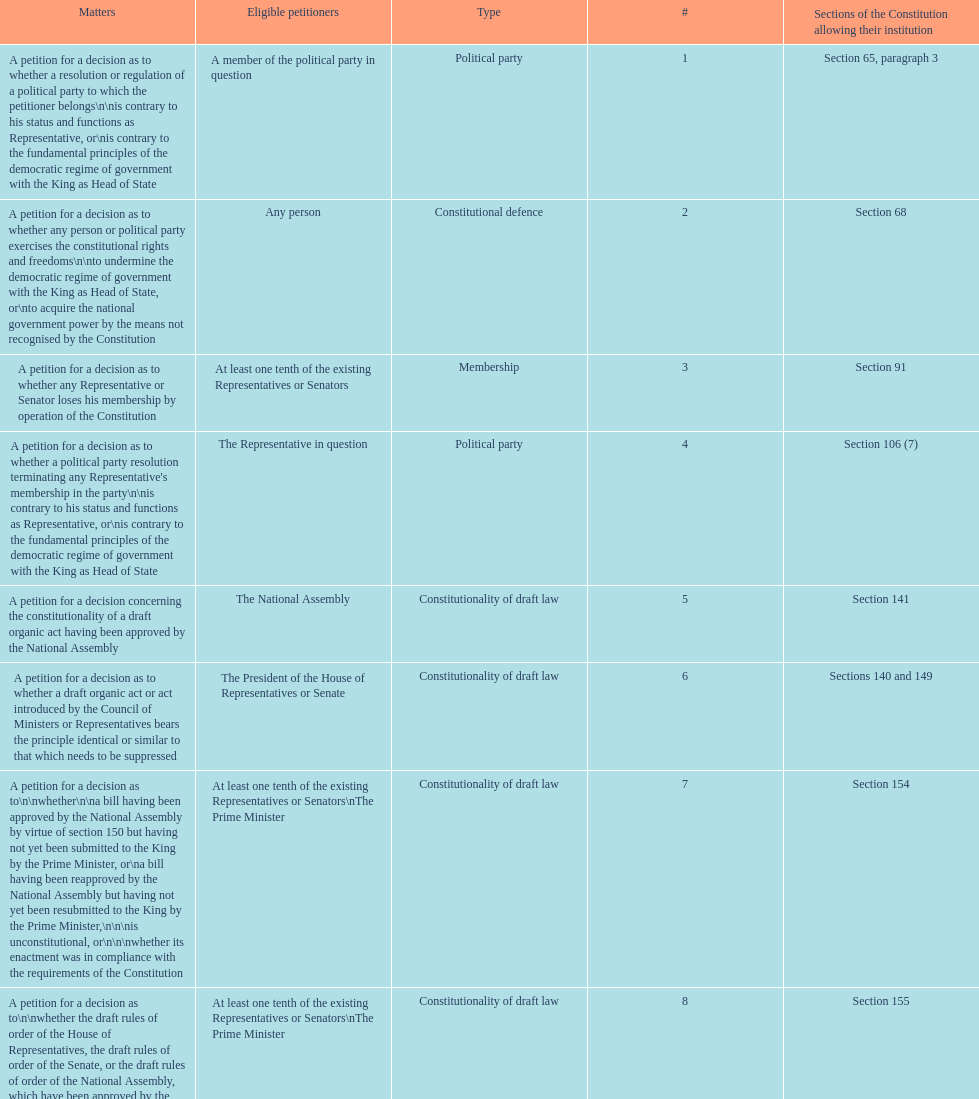How many matters have political party as their "type"? 3. 